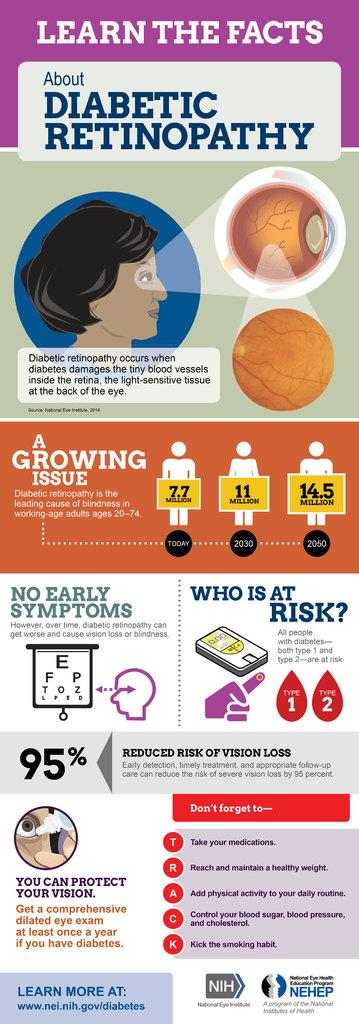What is present on the poster in the image? The poster contains text and images. Can you describe the content of the poster? The poster contains text and images, but the specific content cannot be determined from the provided facts. What is the price of the milk shown in the image? There is no milk present in the image, so it is not possible to determine the price of any milk. 